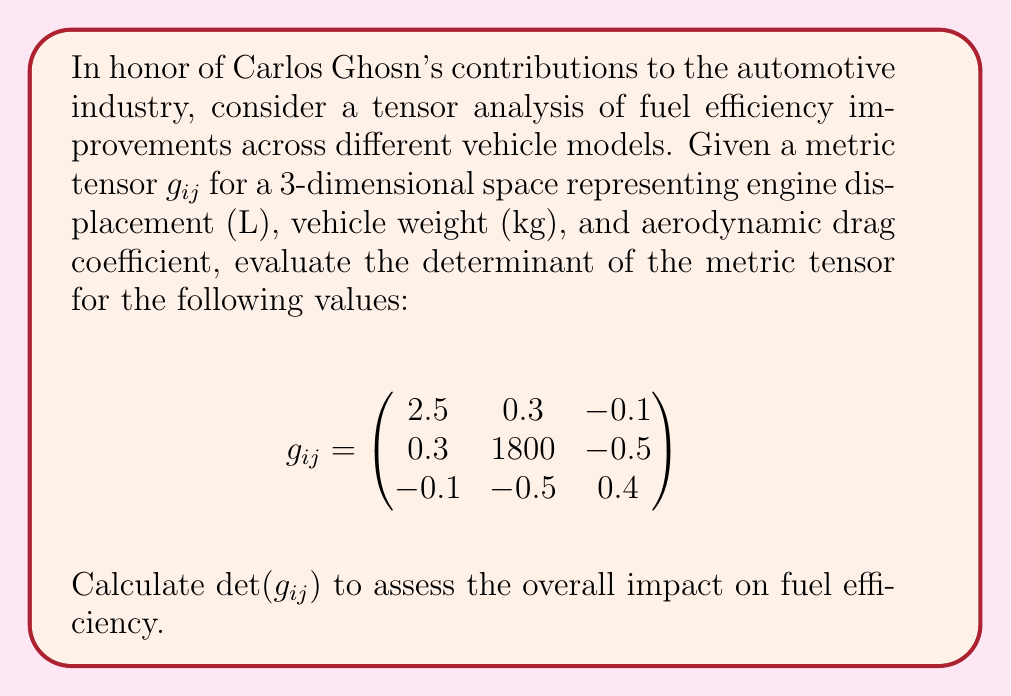Solve this math problem. To evaluate the determinant of the given 3x3 metric tensor $g_{ij}$, we'll use the following steps:

1) For a 3x3 matrix, the determinant is calculated using the formula:

   $\det(A) = a_{11}(a_{22}a_{33} - a_{23}a_{32}) - a_{12}(a_{21}a_{33} - a_{23}a_{31}) + a_{13}(a_{21}a_{32} - a_{22}a_{31})$

2) In our case:
   $a_{11} = 2.5$, $a_{12} = 0.3$, $a_{13} = -0.1$
   $a_{21} = 0.3$, $a_{22} = 1800$, $a_{23} = -0.5$
   $a_{31} = -0.1$, $a_{32} = -0.5$, $a_{33} = 0.4$

3) Let's calculate each term:
   
   Term 1: $2.5 \times (1800 \times 0.4 - (-0.5) \times (-0.5)) = 2.5 \times (720 - 0.25) = 2.5 \times 719.75 = 1799.375$
   
   Term 2: $-0.3 \times (0.3 \times 0.4 - (-0.5) \times (-0.1)) = -0.3 \times (0.12 - 0.05) = -0.3 \times 0.07 = -0.021$
   
   Term 3: $-0.1 \times (0.3 \times (-0.5) - 1800 \times (-0.1)) = -0.1 \times (-0.15 + 180) = -0.1 \times 179.85 = -17.985$

4) Sum up all terms:
   $\det(g_{ij}) = 1799.375 - 0.021 - 17.985 = 1781.369$

The positive determinant indicates that the metric preserves orientation in the space of engine displacement, vehicle weight, and aerodynamic drag, suggesting a coherent relationship between these factors in improving fuel efficiency.
Answer: $\det(g_{ij}) = 1781.369$ 